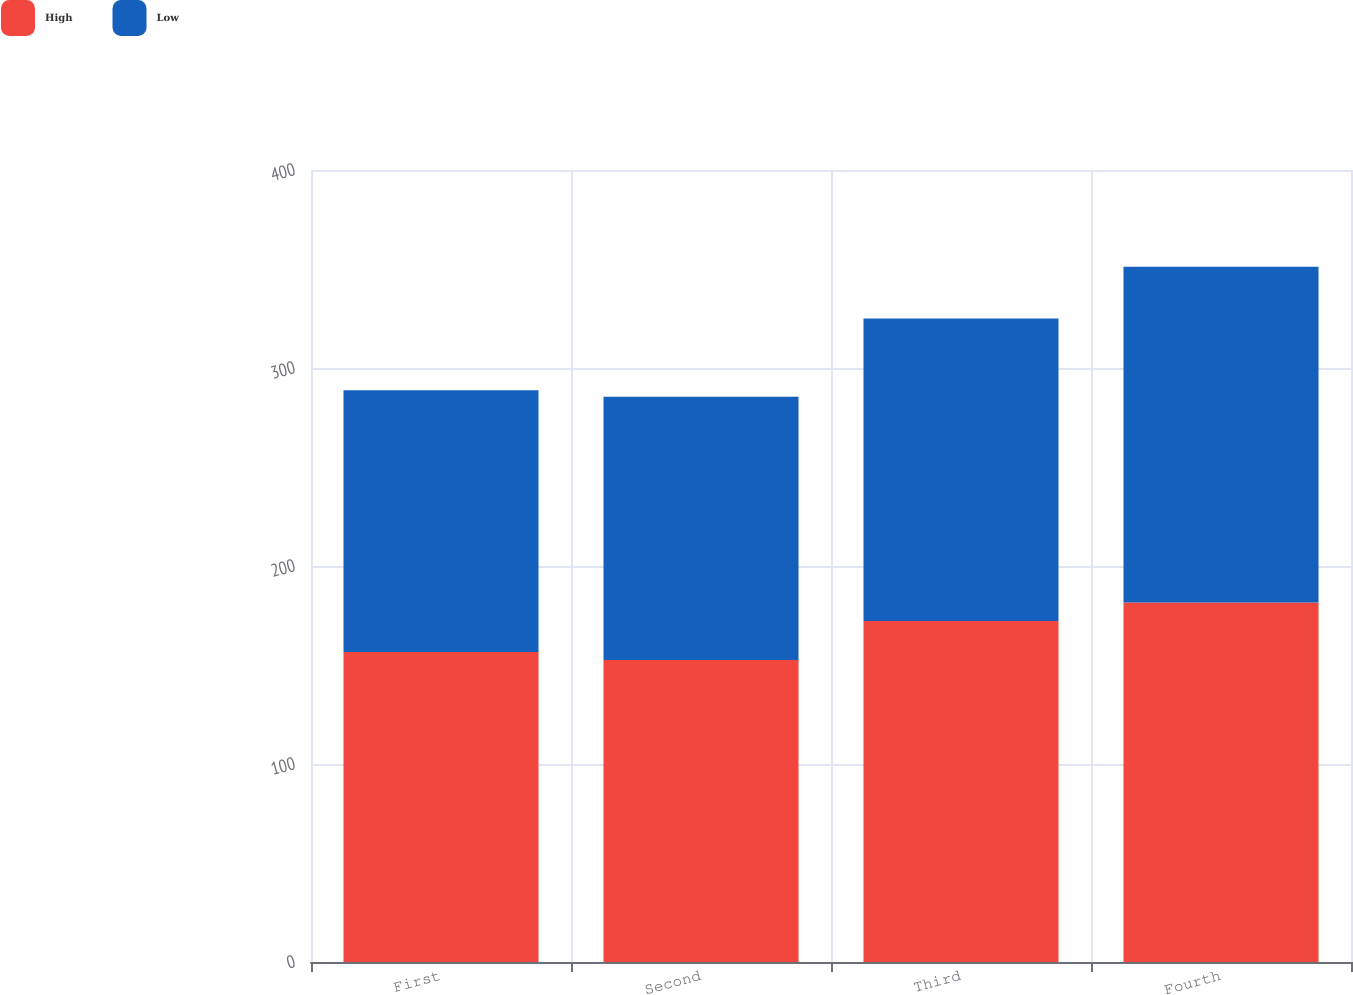Convert chart to OTSL. <chart><loc_0><loc_0><loc_500><loc_500><stacked_bar_chart><ecel><fcel>First<fcel>Second<fcel>Third<fcel>Fourth<nl><fcel>High<fcel>156.53<fcel>152.54<fcel>172.19<fcel>181.55<nl><fcel>Low<fcel>132.19<fcel>132.88<fcel>152.86<fcel>169.64<nl></chart> 